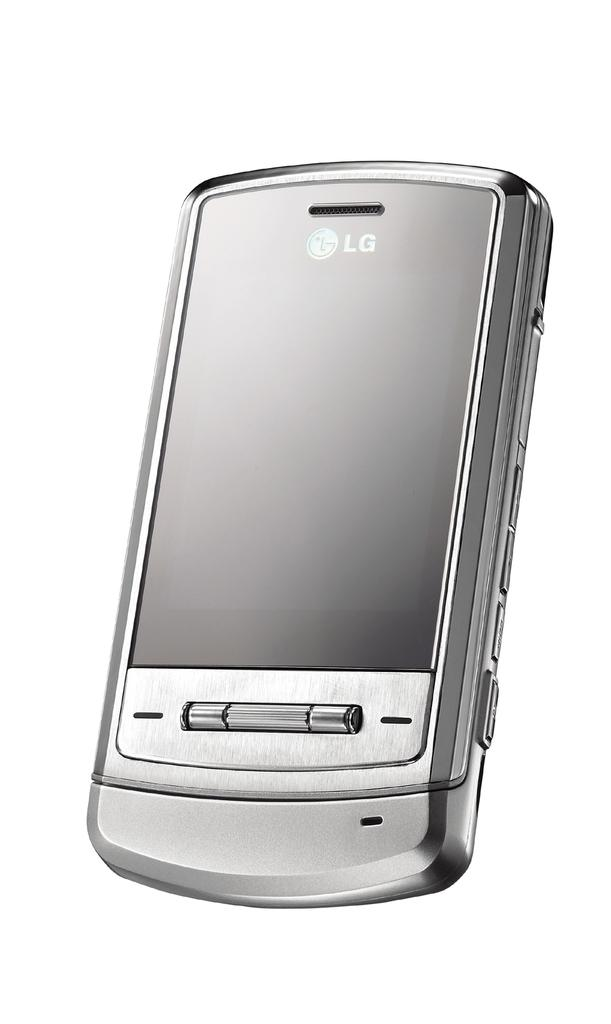Provide a one-sentence caption for the provided image. A silver cell phone, branded LG, is displayed on a white background. 